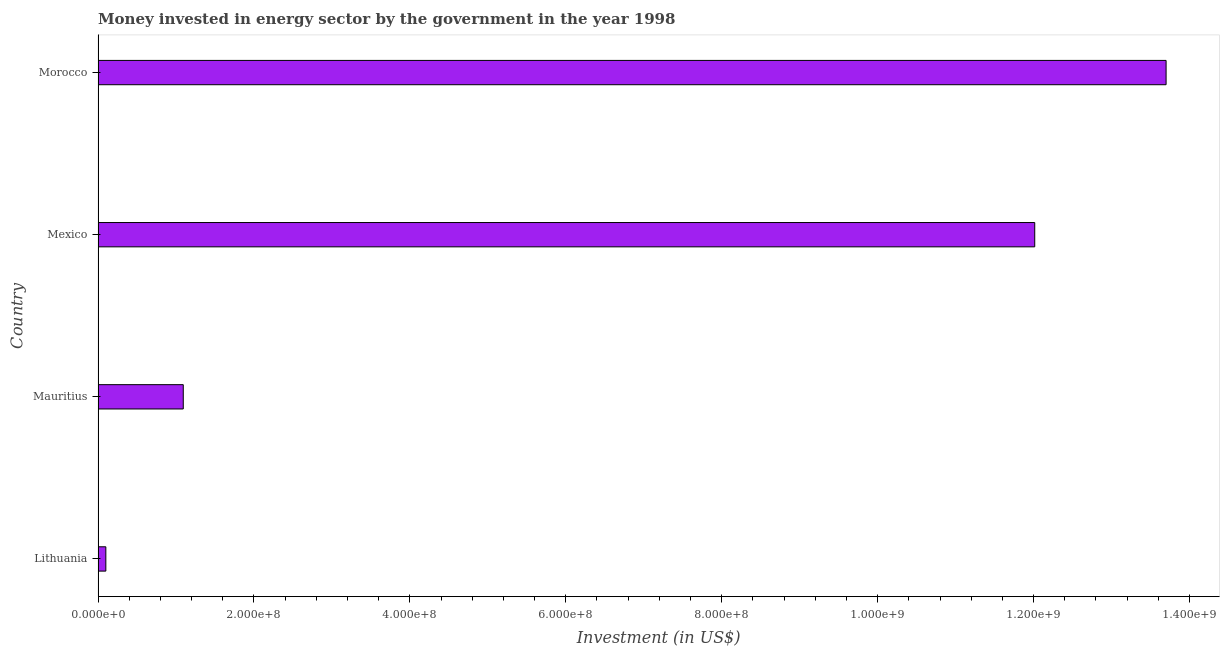Does the graph contain any zero values?
Offer a terse response. No. What is the title of the graph?
Your response must be concise. Money invested in energy sector by the government in the year 1998. What is the label or title of the X-axis?
Provide a short and direct response. Investment (in US$). What is the investment in energy in Mauritius?
Provide a short and direct response. 1.09e+08. Across all countries, what is the maximum investment in energy?
Offer a terse response. 1.37e+09. Across all countries, what is the minimum investment in energy?
Provide a short and direct response. 1.00e+07. In which country was the investment in energy maximum?
Ensure brevity in your answer.  Morocco. In which country was the investment in energy minimum?
Give a very brief answer. Lithuania. What is the sum of the investment in energy?
Ensure brevity in your answer.  2.69e+09. What is the difference between the investment in energy in Mauritius and Mexico?
Provide a succinct answer. -1.09e+09. What is the average investment in energy per country?
Ensure brevity in your answer.  6.73e+08. What is the median investment in energy?
Provide a short and direct response. 6.55e+08. What is the ratio of the investment in energy in Mexico to that in Morocco?
Your answer should be very brief. 0.88. Is the difference between the investment in energy in Mauritius and Mexico greater than the difference between any two countries?
Ensure brevity in your answer.  No. What is the difference between the highest and the second highest investment in energy?
Your answer should be compact. 1.68e+08. What is the difference between the highest and the lowest investment in energy?
Your answer should be very brief. 1.36e+09. How many bars are there?
Give a very brief answer. 4. Are the values on the major ticks of X-axis written in scientific E-notation?
Your response must be concise. Yes. What is the Investment (in US$) in Mauritius?
Keep it short and to the point. 1.09e+08. What is the Investment (in US$) in Mexico?
Offer a very short reply. 1.20e+09. What is the Investment (in US$) of Morocco?
Offer a very short reply. 1.37e+09. What is the difference between the Investment (in US$) in Lithuania and Mauritius?
Offer a very short reply. -9.93e+07. What is the difference between the Investment (in US$) in Lithuania and Mexico?
Your response must be concise. -1.19e+09. What is the difference between the Investment (in US$) in Lithuania and Morocco?
Offer a terse response. -1.36e+09. What is the difference between the Investment (in US$) in Mauritius and Mexico?
Your response must be concise. -1.09e+09. What is the difference between the Investment (in US$) in Mauritius and Morocco?
Offer a very short reply. -1.26e+09. What is the difference between the Investment (in US$) in Mexico and Morocco?
Make the answer very short. -1.68e+08. What is the ratio of the Investment (in US$) in Lithuania to that in Mauritius?
Ensure brevity in your answer.  0.09. What is the ratio of the Investment (in US$) in Lithuania to that in Mexico?
Provide a short and direct response. 0.01. What is the ratio of the Investment (in US$) in Lithuania to that in Morocco?
Offer a very short reply. 0.01. What is the ratio of the Investment (in US$) in Mauritius to that in Mexico?
Offer a very short reply. 0.09. What is the ratio of the Investment (in US$) in Mexico to that in Morocco?
Offer a terse response. 0.88. 